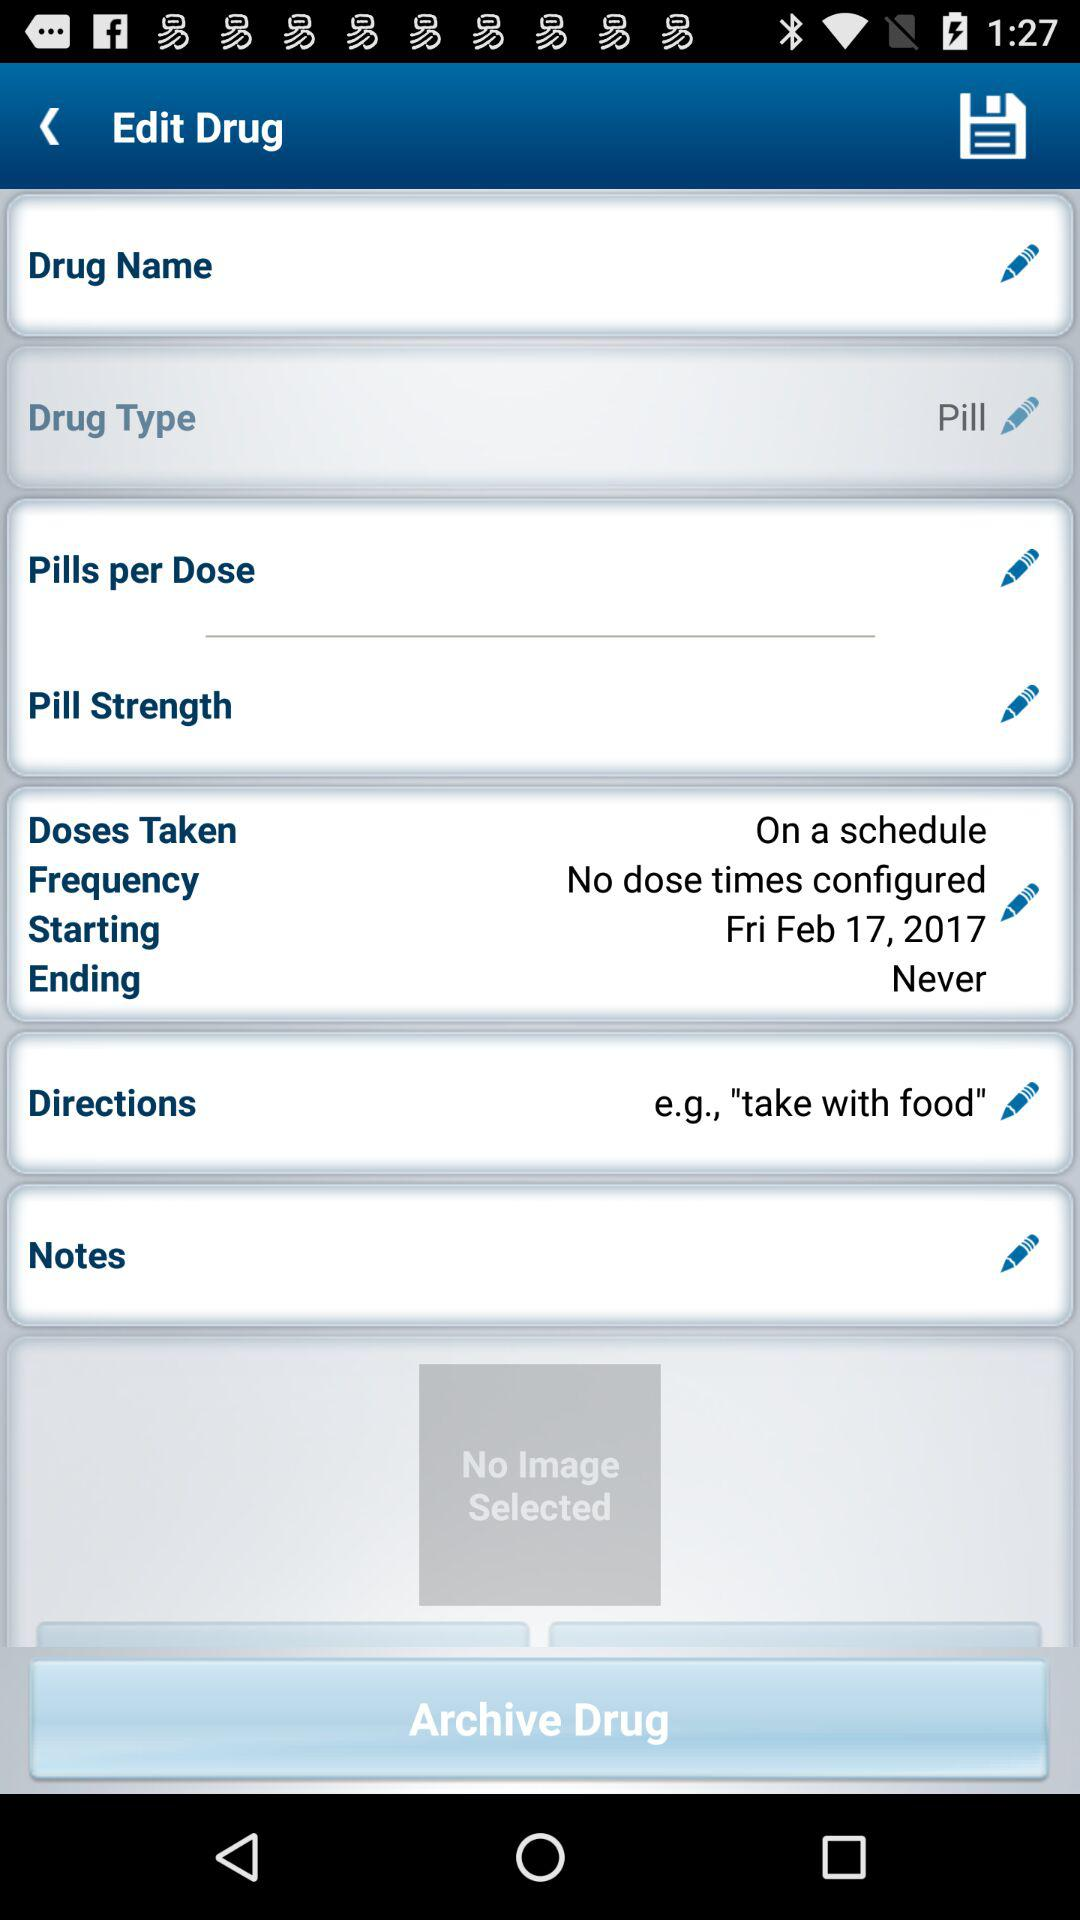What is the frequency of the doses taken? The frequency of the doses taken is "No dose times configured". 